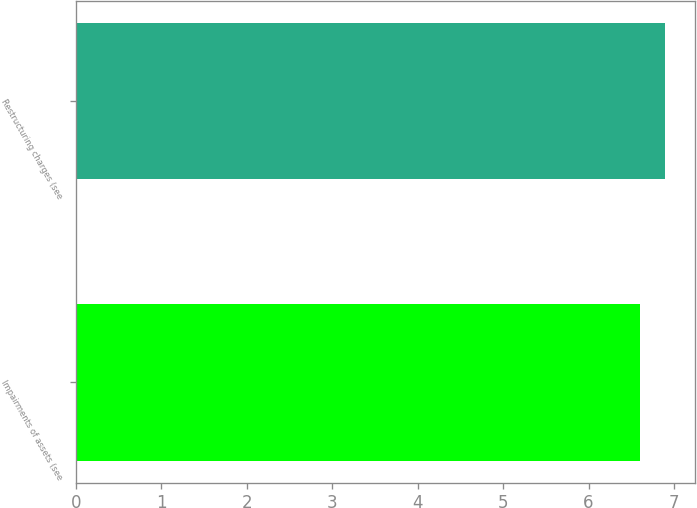Convert chart to OTSL. <chart><loc_0><loc_0><loc_500><loc_500><bar_chart><fcel>Impairments of assets (see<fcel>Restructuring charges (see<nl><fcel>6.6<fcel>6.9<nl></chart> 